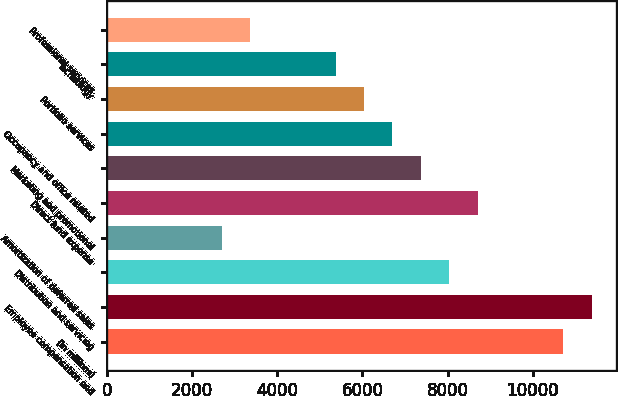Convert chart. <chart><loc_0><loc_0><loc_500><loc_500><bar_chart><fcel>(in millions)<fcel>Employee compensation and<fcel>Distribution and servicing<fcel>Amortization of deferred sales<fcel>Direct fund expense<fcel>Marketing and promotional<fcel>Occupancy and office related<fcel>Portfolio services<fcel>Technology<fcel>Professional services<nl><fcel>10715.2<fcel>11383.4<fcel>8042.4<fcel>2696.8<fcel>8710.6<fcel>7374.2<fcel>6706<fcel>6037.8<fcel>5369.6<fcel>3365<nl></chart> 